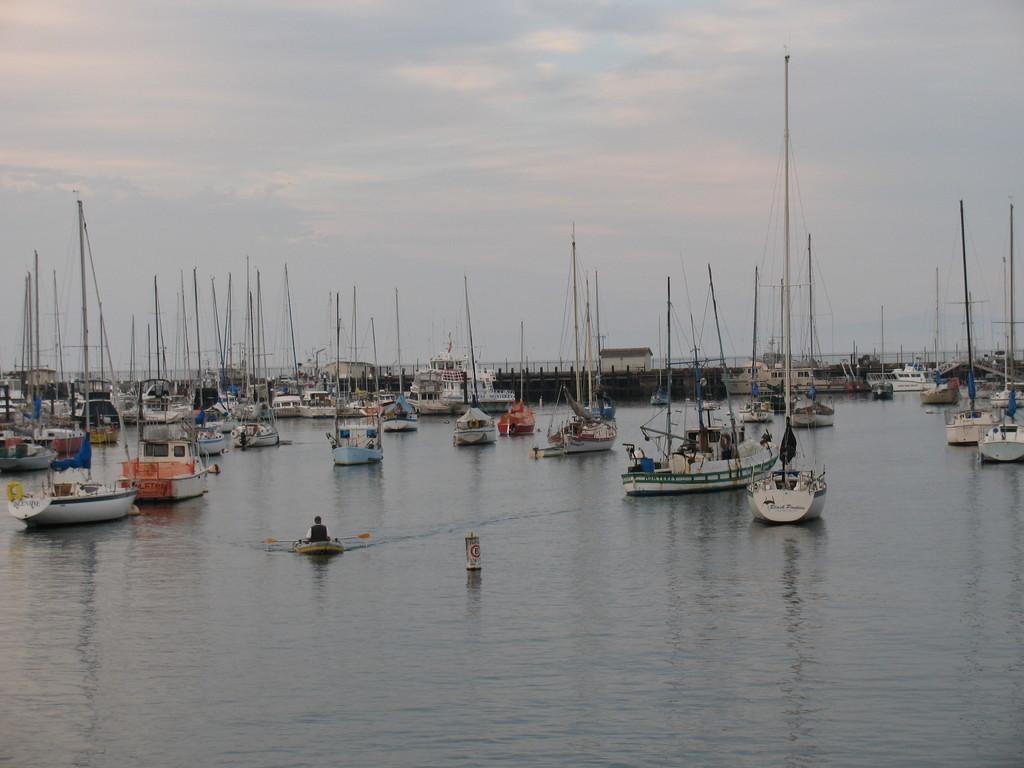Can you describe this image briefly? In this picture I can see many boats and ships on the water. In the bottom left there is a man who is sitting on the boat. At the top I can see the sky and clouds. In the background I can see the building, trees and bridge. 